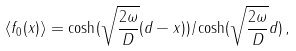Convert formula to latex. <formula><loc_0><loc_0><loc_500><loc_500>\langle f _ { 0 } ( x ) \rangle = \cosh ( \sqrt { \frac { 2 \omega } { D } } ( d - x ) ) / \cosh ( \sqrt { \frac { 2 \omega } { D } } d ) \, ,</formula> 